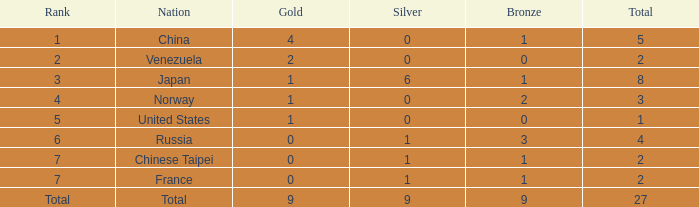What is the total sum when the rank is equal to 2? 2.0. 